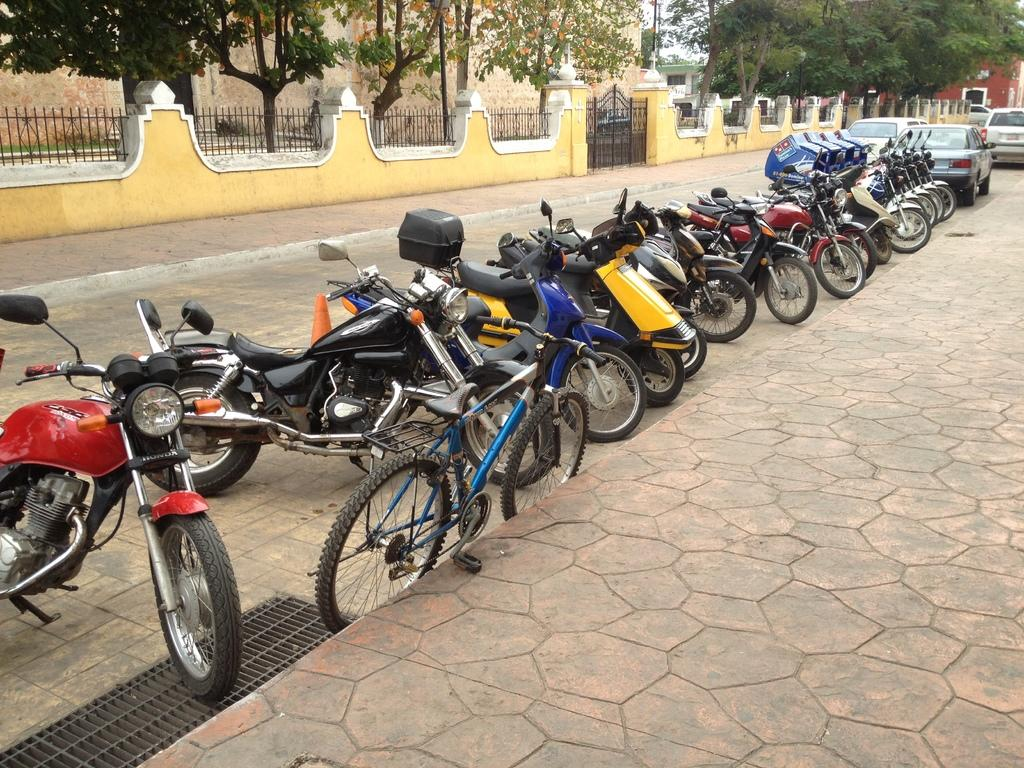What type of vehicles are present in the image? There are motorcycles, a bicycle, and cars in the image. What structures can be seen in the image? There is a fence, a gate, and buildings in the image. What type of natural elements are present in the image? There are trees in the image. What part of the natural environment is visible in the image? The sky is visible in the image. How does the girl compare to the train in the image? There is no girl or train present in the image. What type of comparison can be made between the motorcycles and the train in the image? There is no train present in the image, so no such comparison can be made. 